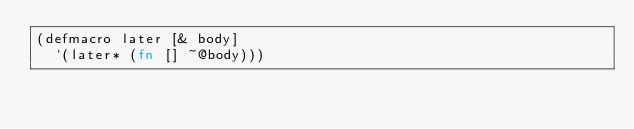<code> <loc_0><loc_0><loc_500><loc_500><_Clojure_>(defmacro later [& body]
  `(later* (fn [] ~@body)))
</code> 